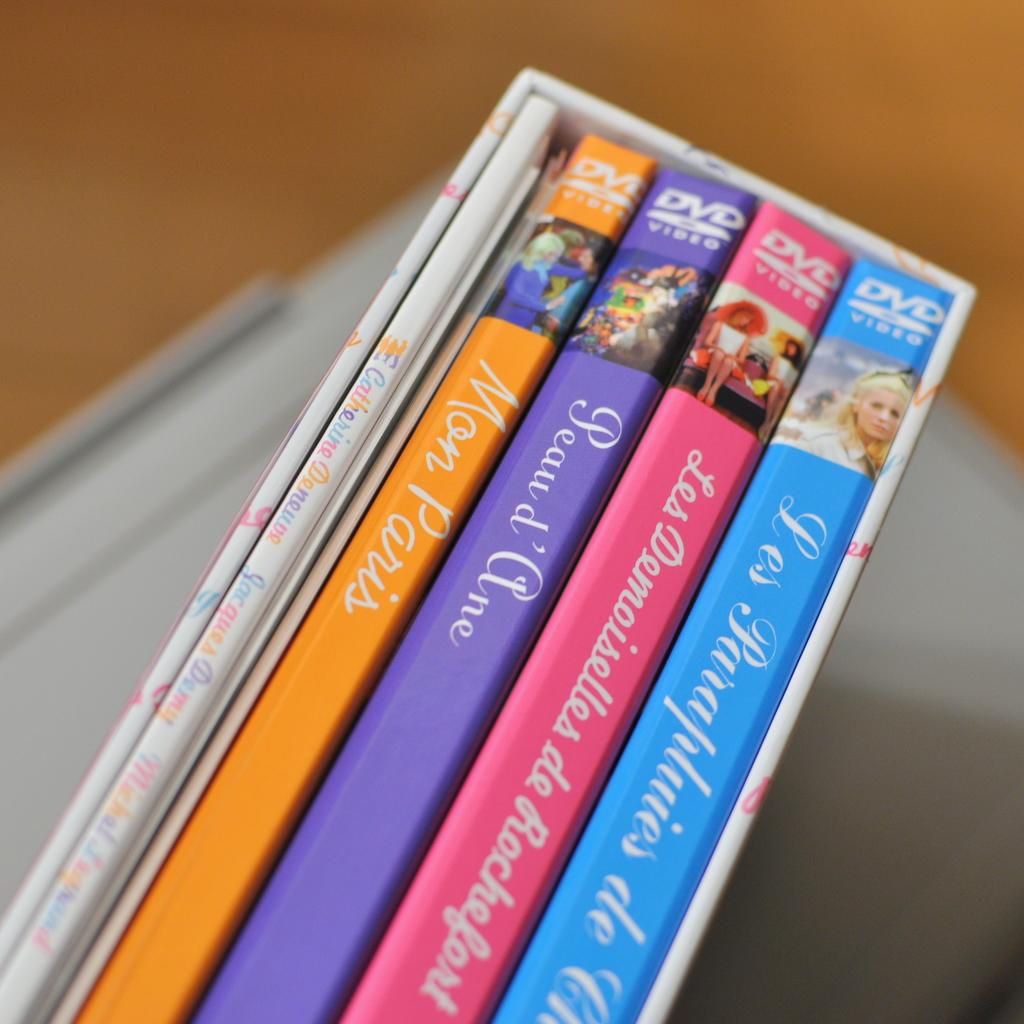<image>
Relay a brief, clear account of the picture shown. Some DVDs with French titles, one of which is Mon Paris. 